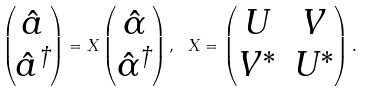Convert formula to latex. <formula><loc_0><loc_0><loc_500><loc_500>\begin{pmatrix} \hat { a } \\ \hat { a } ^ { \dag } \end{pmatrix} = X \begin{pmatrix} \hat { \alpha } \\ \hat { \alpha } ^ { \dag } \end{pmatrix} , \ X = \begin{pmatrix} U & V \\ V ^ { * } & U ^ { * } \end{pmatrix} .</formula> 